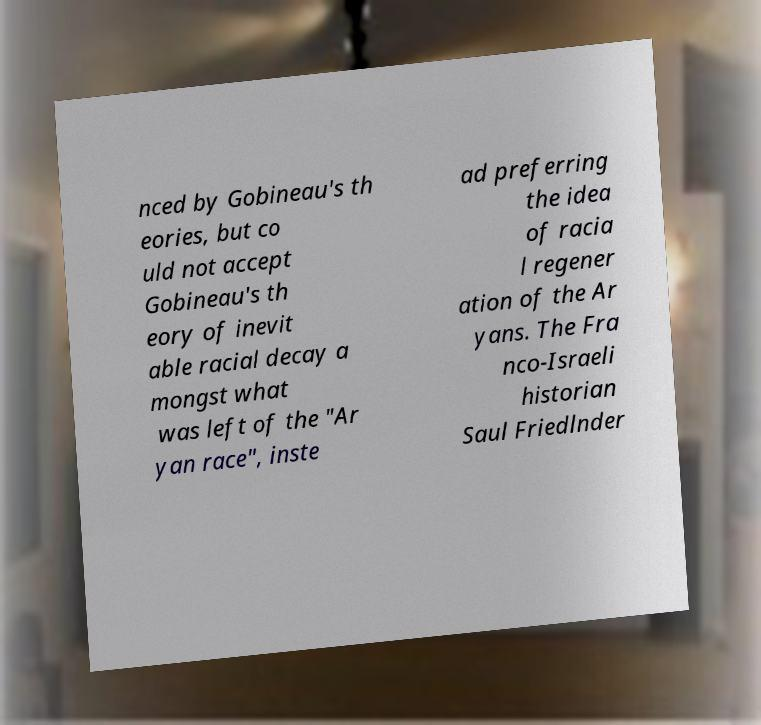Can you accurately transcribe the text from the provided image for me? nced by Gobineau's th eories, but co uld not accept Gobineau's th eory of inevit able racial decay a mongst what was left of the "Ar yan race", inste ad preferring the idea of racia l regener ation of the Ar yans. The Fra nco-Israeli historian Saul Friedlnder 